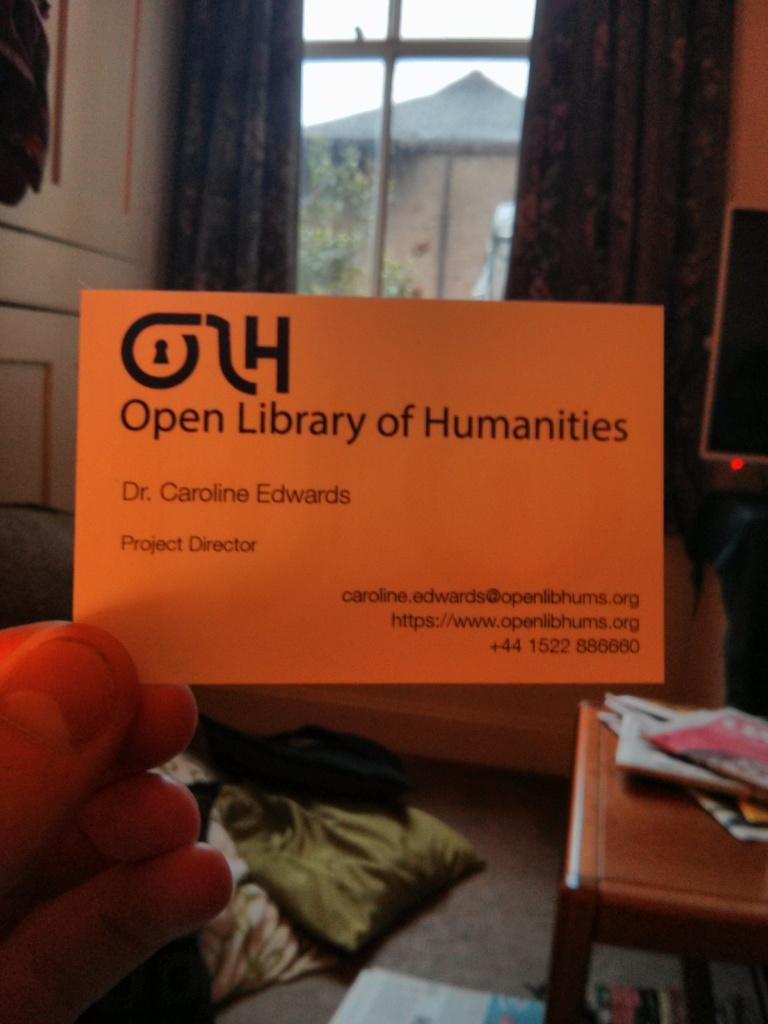<image>
Provide a brief description of the given image. A person is holding up a business card that reads Caroline Edwards. 